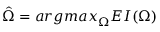<formula> <loc_0><loc_0><loc_500><loc_500>\hat { \Omega } = { \arg \max } _ { \Omega } E I ( \Omega )</formula> 